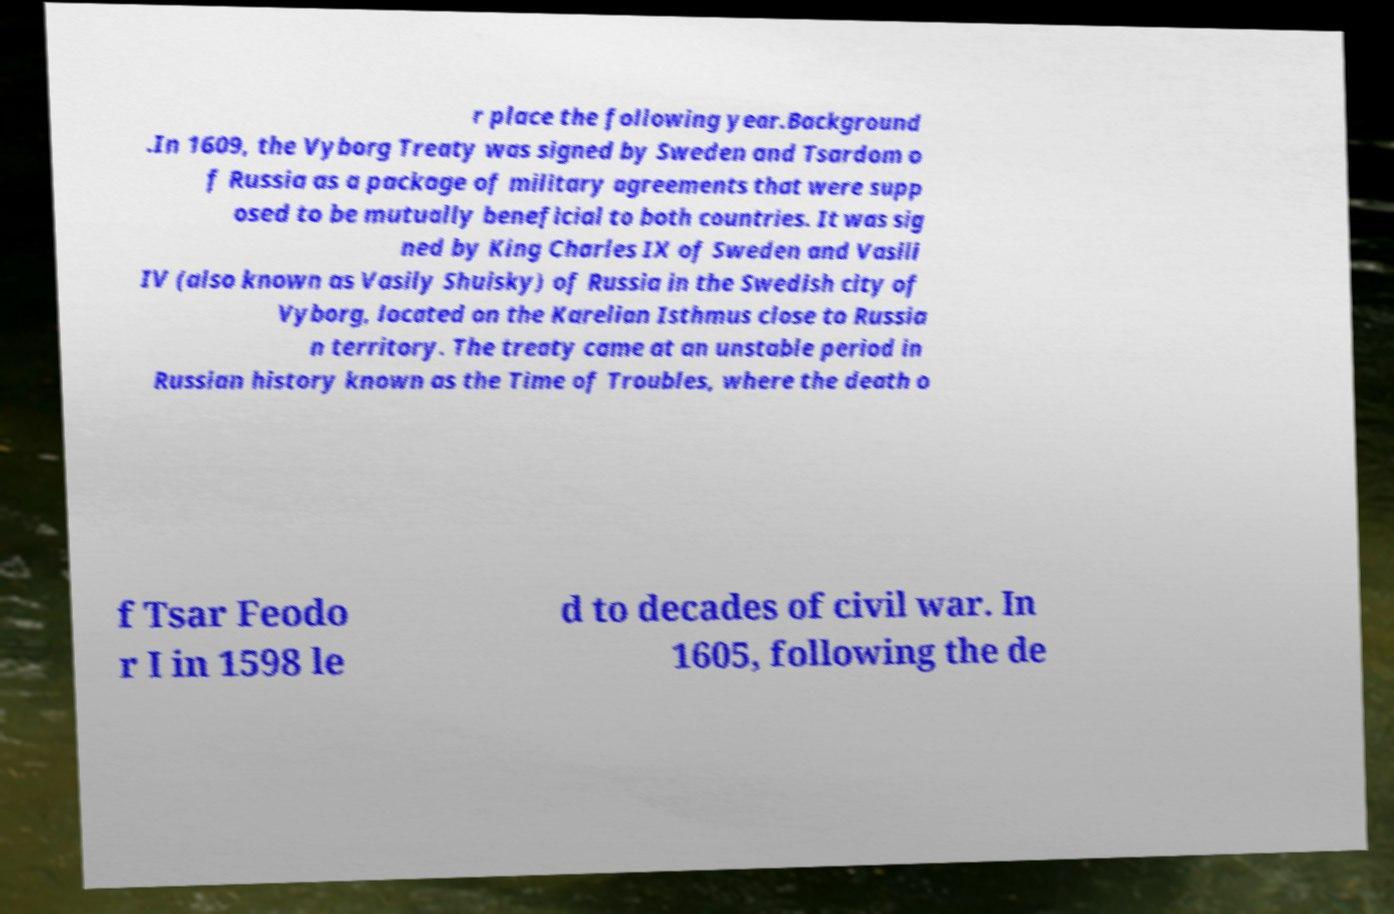Can you accurately transcribe the text from the provided image for me? r place the following year.Background .In 1609, the Vyborg Treaty was signed by Sweden and Tsardom o f Russia as a package of military agreements that were supp osed to be mutually beneficial to both countries. It was sig ned by King Charles IX of Sweden and Vasili IV (also known as Vasily Shuisky) of Russia in the Swedish city of Vyborg, located on the Karelian Isthmus close to Russia n territory. The treaty came at an unstable period in Russian history known as the Time of Troubles, where the death o f Tsar Feodo r I in 1598 le d to decades of civil war. In 1605, following the de 